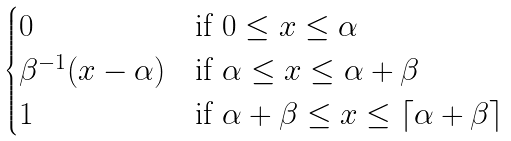Convert formula to latex. <formula><loc_0><loc_0><loc_500><loc_500>\begin{cases} 0 & \text {if $0\leq x\leq\alpha$} \\ \beta ^ { - 1 } ( x - \alpha ) & \text {if $\alpha\leq x\leq \alpha+\beta$} \\ 1 & \text {if $\alpha+\beta\leq x\leq \lceil \alpha+\beta\rceil$} \end{cases}</formula> 